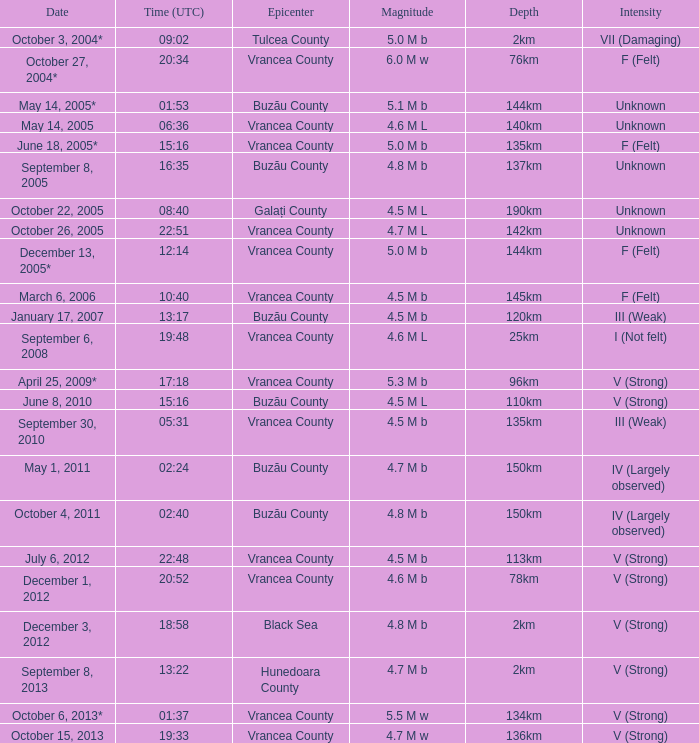How deep was the earthquake that happened at 19:48? 25km. 